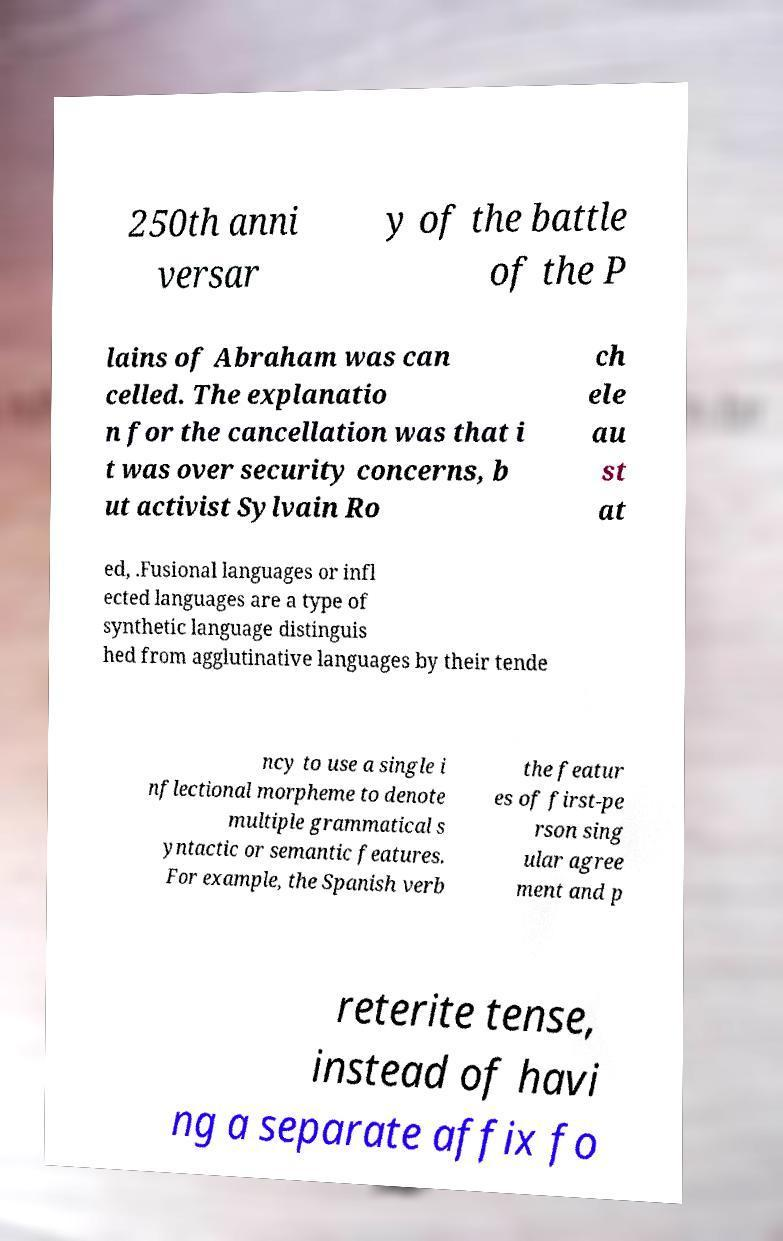Could you assist in decoding the text presented in this image and type it out clearly? 250th anni versar y of the battle of the P lains of Abraham was can celled. The explanatio n for the cancellation was that i t was over security concerns, b ut activist Sylvain Ro ch ele au st at ed, .Fusional languages or infl ected languages are a type of synthetic language distinguis hed from agglutinative languages by their tende ncy to use a single i nflectional morpheme to denote multiple grammatical s yntactic or semantic features. For example, the Spanish verb the featur es of first-pe rson sing ular agree ment and p reterite tense, instead of havi ng a separate affix fo 